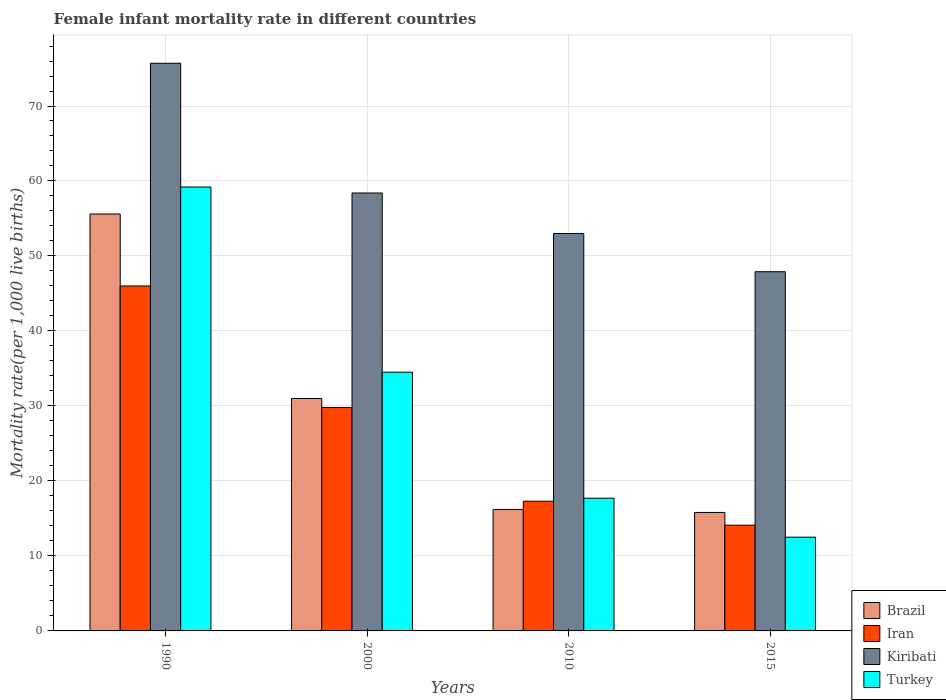How many groups of bars are there?
Offer a very short reply. 4. What is the label of the 4th group of bars from the left?
Provide a succinct answer. 2015. In which year was the female infant mortality rate in Turkey maximum?
Ensure brevity in your answer.  1990. In which year was the female infant mortality rate in Brazil minimum?
Make the answer very short. 2015. What is the total female infant mortality rate in Kiribati in the graph?
Your answer should be very brief. 235. What is the difference between the female infant mortality rate in Brazil in 1990 and that in 2015?
Offer a very short reply. 39.8. What is the difference between the female infant mortality rate in Kiribati in 2015 and the female infant mortality rate in Turkey in 1990?
Your response must be concise. -11.3. What is the average female infant mortality rate in Turkey per year?
Your answer should be compact. 30.98. In the year 2015, what is the difference between the female infant mortality rate in Turkey and female infant mortality rate in Iran?
Provide a succinct answer. -1.6. In how many years, is the female infant mortality rate in Kiribati greater than 2?
Your response must be concise. 4. What is the ratio of the female infant mortality rate in Iran in 1990 to that in 2000?
Offer a terse response. 1.54. What is the difference between the highest and the second highest female infant mortality rate in Iran?
Give a very brief answer. 16.2. What is the difference between the highest and the lowest female infant mortality rate in Iran?
Give a very brief answer. 31.9. Is the sum of the female infant mortality rate in Kiribati in 1990 and 2015 greater than the maximum female infant mortality rate in Turkey across all years?
Make the answer very short. Yes. Is it the case that in every year, the sum of the female infant mortality rate in Iran and female infant mortality rate in Brazil is greater than the sum of female infant mortality rate in Kiribati and female infant mortality rate in Turkey?
Keep it short and to the point. No. What does the 3rd bar from the right in 2015 represents?
Offer a terse response. Iran. How many bars are there?
Offer a very short reply. 16. How many years are there in the graph?
Make the answer very short. 4. Are the values on the major ticks of Y-axis written in scientific E-notation?
Keep it short and to the point. No. Does the graph contain any zero values?
Ensure brevity in your answer.  No. Where does the legend appear in the graph?
Offer a terse response. Bottom right. What is the title of the graph?
Keep it short and to the point. Female infant mortality rate in different countries. What is the label or title of the X-axis?
Keep it short and to the point. Years. What is the label or title of the Y-axis?
Ensure brevity in your answer.  Mortality rate(per 1,0 live births). What is the Mortality rate(per 1,000 live births) in Brazil in 1990?
Provide a short and direct response. 55.6. What is the Mortality rate(per 1,000 live births) in Kiribati in 1990?
Make the answer very short. 75.7. What is the Mortality rate(per 1,000 live births) of Turkey in 1990?
Offer a very short reply. 59.2. What is the Mortality rate(per 1,000 live births) of Iran in 2000?
Give a very brief answer. 29.8. What is the Mortality rate(per 1,000 live births) of Kiribati in 2000?
Give a very brief answer. 58.4. What is the Mortality rate(per 1,000 live births) in Turkey in 2000?
Offer a terse response. 34.5. What is the Mortality rate(per 1,000 live births) of Kiribati in 2010?
Your answer should be compact. 53. What is the Mortality rate(per 1,000 live births) of Turkey in 2010?
Make the answer very short. 17.7. What is the Mortality rate(per 1,000 live births) in Brazil in 2015?
Ensure brevity in your answer.  15.8. What is the Mortality rate(per 1,000 live births) of Iran in 2015?
Your response must be concise. 14.1. What is the Mortality rate(per 1,000 live births) in Kiribati in 2015?
Offer a very short reply. 47.9. Across all years, what is the maximum Mortality rate(per 1,000 live births) of Brazil?
Your answer should be compact. 55.6. Across all years, what is the maximum Mortality rate(per 1,000 live births) in Kiribati?
Your response must be concise. 75.7. Across all years, what is the maximum Mortality rate(per 1,000 live births) in Turkey?
Keep it short and to the point. 59.2. Across all years, what is the minimum Mortality rate(per 1,000 live births) of Brazil?
Your answer should be compact. 15.8. Across all years, what is the minimum Mortality rate(per 1,000 live births) in Iran?
Your answer should be compact. 14.1. Across all years, what is the minimum Mortality rate(per 1,000 live births) of Kiribati?
Your response must be concise. 47.9. Across all years, what is the minimum Mortality rate(per 1,000 live births) of Turkey?
Ensure brevity in your answer.  12.5. What is the total Mortality rate(per 1,000 live births) in Brazil in the graph?
Your answer should be compact. 118.6. What is the total Mortality rate(per 1,000 live births) in Iran in the graph?
Offer a terse response. 107.2. What is the total Mortality rate(per 1,000 live births) in Kiribati in the graph?
Your answer should be compact. 235. What is the total Mortality rate(per 1,000 live births) of Turkey in the graph?
Your answer should be very brief. 123.9. What is the difference between the Mortality rate(per 1,000 live births) of Brazil in 1990 and that in 2000?
Ensure brevity in your answer.  24.6. What is the difference between the Mortality rate(per 1,000 live births) in Iran in 1990 and that in 2000?
Your answer should be compact. 16.2. What is the difference between the Mortality rate(per 1,000 live births) in Turkey in 1990 and that in 2000?
Offer a very short reply. 24.7. What is the difference between the Mortality rate(per 1,000 live births) in Brazil in 1990 and that in 2010?
Keep it short and to the point. 39.4. What is the difference between the Mortality rate(per 1,000 live births) in Iran in 1990 and that in 2010?
Your response must be concise. 28.7. What is the difference between the Mortality rate(per 1,000 live births) of Kiribati in 1990 and that in 2010?
Your response must be concise. 22.7. What is the difference between the Mortality rate(per 1,000 live births) of Turkey in 1990 and that in 2010?
Offer a very short reply. 41.5. What is the difference between the Mortality rate(per 1,000 live births) in Brazil in 1990 and that in 2015?
Your response must be concise. 39.8. What is the difference between the Mortality rate(per 1,000 live births) in Iran in 1990 and that in 2015?
Make the answer very short. 31.9. What is the difference between the Mortality rate(per 1,000 live births) of Kiribati in 1990 and that in 2015?
Offer a terse response. 27.8. What is the difference between the Mortality rate(per 1,000 live births) in Turkey in 1990 and that in 2015?
Keep it short and to the point. 46.7. What is the difference between the Mortality rate(per 1,000 live births) of Brazil in 2000 and that in 2015?
Your answer should be compact. 15.2. What is the difference between the Mortality rate(per 1,000 live births) of Kiribati in 2000 and that in 2015?
Your answer should be compact. 10.5. What is the difference between the Mortality rate(per 1,000 live births) of Kiribati in 2010 and that in 2015?
Provide a succinct answer. 5.1. What is the difference between the Mortality rate(per 1,000 live births) in Turkey in 2010 and that in 2015?
Offer a very short reply. 5.2. What is the difference between the Mortality rate(per 1,000 live births) in Brazil in 1990 and the Mortality rate(per 1,000 live births) in Iran in 2000?
Your answer should be very brief. 25.8. What is the difference between the Mortality rate(per 1,000 live births) of Brazil in 1990 and the Mortality rate(per 1,000 live births) of Kiribati in 2000?
Give a very brief answer. -2.8. What is the difference between the Mortality rate(per 1,000 live births) in Brazil in 1990 and the Mortality rate(per 1,000 live births) in Turkey in 2000?
Offer a terse response. 21.1. What is the difference between the Mortality rate(per 1,000 live births) in Kiribati in 1990 and the Mortality rate(per 1,000 live births) in Turkey in 2000?
Offer a very short reply. 41.2. What is the difference between the Mortality rate(per 1,000 live births) of Brazil in 1990 and the Mortality rate(per 1,000 live births) of Iran in 2010?
Your response must be concise. 38.3. What is the difference between the Mortality rate(per 1,000 live births) in Brazil in 1990 and the Mortality rate(per 1,000 live births) in Kiribati in 2010?
Your answer should be very brief. 2.6. What is the difference between the Mortality rate(per 1,000 live births) in Brazil in 1990 and the Mortality rate(per 1,000 live births) in Turkey in 2010?
Your answer should be compact. 37.9. What is the difference between the Mortality rate(per 1,000 live births) of Iran in 1990 and the Mortality rate(per 1,000 live births) of Kiribati in 2010?
Your answer should be compact. -7. What is the difference between the Mortality rate(per 1,000 live births) of Iran in 1990 and the Mortality rate(per 1,000 live births) of Turkey in 2010?
Your answer should be compact. 28.3. What is the difference between the Mortality rate(per 1,000 live births) in Brazil in 1990 and the Mortality rate(per 1,000 live births) in Iran in 2015?
Ensure brevity in your answer.  41.5. What is the difference between the Mortality rate(per 1,000 live births) of Brazil in 1990 and the Mortality rate(per 1,000 live births) of Kiribati in 2015?
Your answer should be very brief. 7.7. What is the difference between the Mortality rate(per 1,000 live births) in Brazil in 1990 and the Mortality rate(per 1,000 live births) in Turkey in 2015?
Offer a terse response. 43.1. What is the difference between the Mortality rate(per 1,000 live births) of Iran in 1990 and the Mortality rate(per 1,000 live births) of Kiribati in 2015?
Provide a succinct answer. -1.9. What is the difference between the Mortality rate(per 1,000 live births) in Iran in 1990 and the Mortality rate(per 1,000 live births) in Turkey in 2015?
Offer a terse response. 33.5. What is the difference between the Mortality rate(per 1,000 live births) in Kiribati in 1990 and the Mortality rate(per 1,000 live births) in Turkey in 2015?
Offer a terse response. 63.2. What is the difference between the Mortality rate(per 1,000 live births) of Brazil in 2000 and the Mortality rate(per 1,000 live births) of Iran in 2010?
Provide a short and direct response. 13.7. What is the difference between the Mortality rate(per 1,000 live births) in Brazil in 2000 and the Mortality rate(per 1,000 live births) in Turkey in 2010?
Your answer should be very brief. 13.3. What is the difference between the Mortality rate(per 1,000 live births) of Iran in 2000 and the Mortality rate(per 1,000 live births) of Kiribati in 2010?
Provide a succinct answer. -23.2. What is the difference between the Mortality rate(per 1,000 live births) of Iran in 2000 and the Mortality rate(per 1,000 live births) of Turkey in 2010?
Offer a very short reply. 12.1. What is the difference between the Mortality rate(per 1,000 live births) in Kiribati in 2000 and the Mortality rate(per 1,000 live births) in Turkey in 2010?
Your response must be concise. 40.7. What is the difference between the Mortality rate(per 1,000 live births) in Brazil in 2000 and the Mortality rate(per 1,000 live births) in Kiribati in 2015?
Offer a very short reply. -16.9. What is the difference between the Mortality rate(per 1,000 live births) of Iran in 2000 and the Mortality rate(per 1,000 live births) of Kiribati in 2015?
Provide a succinct answer. -18.1. What is the difference between the Mortality rate(per 1,000 live births) in Iran in 2000 and the Mortality rate(per 1,000 live births) in Turkey in 2015?
Give a very brief answer. 17.3. What is the difference between the Mortality rate(per 1,000 live births) of Kiribati in 2000 and the Mortality rate(per 1,000 live births) of Turkey in 2015?
Provide a short and direct response. 45.9. What is the difference between the Mortality rate(per 1,000 live births) of Brazil in 2010 and the Mortality rate(per 1,000 live births) of Kiribati in 2015?
Give a very brief answer. -31.7. What is the difference between the Mortality rate(per 1,000 live births) in Iran in 2010 and the Mortality rate(per 1,000 live births) in Kiribati in 2015?
Make the answer very short. -30.6. What is the difference between the Mortality rate(per 1,000 live births) of Kiribati in 2010 and the Mortality rate(per 1,000 live births) of Turkey in 2015?
Provide a short and direct response. 40.5. What is the average Mortality rate(per 1,000 live births) of Brazil per year?
Your response must be concise. 29.65. What is the average Mortality rate(per 1,000 live births) of Iran per year?
Your answer should be compact. 26.8. What is the average Mortality rate(per 1,000 live births) in Kiribati per year?
Provide a short and direct response. 58.75. What is the average Mortality rate(per 1,000 live births) of Turkey per year?
Your response must be concise. 30.98. In the year 1990, what is the difference between the Mortality rate(per 1,000 live births) in Brazil and Mortality rate(per 1,000 live births) in Iran?
Your answer should be compact. 9.6. In the year 1990, what is the difference between the Mortality rate(per 1,000 live births) of Brazil and Mortality rate(per 1,000 live births) of Kiribati?
Your answer should be very brief. -20.1. In the year 1990, what is the difference between the Mortality rate(per 1,000 live births) of Brazil and Mortality rate(per 1,000 live births) of Turkey?
Provide a short and direct response. -3.6. In the year 1990, what is the difference between the Mortality rate(per 1,000 live births) of Iran and Mortality rate(per 1,000 live births) of Kiribati?
Offer a terse response. -29.7. In the year 1990, what is the difference between the Mortality rate(per 1,000 live births) of Iran and Mortality rate(per 1,000 live births) of Turkey?
Give a very brief answer. -13.2. In the year 2000, what is the difference between the Mortality rate(per 1,000 live births) of Brazil and Mortality rate(per 1,000 live births) of Iran?
Your response must be concise. 1.2. In the year 2000, what is the difference between the Mortality rate(per 1,000 live births) in Brazil and Mortality rate(per 1,000 live births) in Kiribati?
Your response must be concise. -27.4. In the year 2000, what is the difference between the Mortality rate(per 1,000 live births) in Iran and Mortality rate(per 1,000 live births) in Kiribati?
Keep it short and to the point. -28.6. In the year 2000, what is the difference between the Mortality rate(per 1,000 live births) in Iran and Mortality rate(per 1,000 live births) in Turkey?
Provide a short and direct response. -4.7. In the year 2000, what is the difference between the Mortality rate(per 1,000 live births) in Kiribati and Mortality rate(per 1,000 live births) in Turkey?
Offer a terse response. 23.9. In the year 2010, what is the difference between the Mortality rate(per 1,000 live births) in Brazil and Mortality rate(per 1,000 live births) in Iran?
Provide a short and direct response. -1.1. In the year 2010, what is the difference between the Mortality rate(per 1,000 live births) in Brazil and Mortality rate(per 1,000 live births) in Kiribati?
Keep it short and to the point. -36.8. In the year 2010, what is the difference between the Mortality rate(per 1,000 live births) in Brazil and Mortality rate(per 1,000 live births) in Turkey?
Provide a short and direct response. -1.5. In the year 2010, what is the difference between the Mortality rate(per 1,000 live births) in Iran and Mortality rate(per 1,000 live births) in Kiribati?
Offer a terse response. -35.7. In the year 2010, what is the difference between the Mortality rate(per 1,000 live births) of Kiribati and Mortality rate(per 1,000 live births) of Turkey?
Your answer should be compact. 35.3. In the year 2015, what is the difference between the Mortality rate(per 1,000 live births) of Brazil and Mortality rate(per 1,000 live births) of Iran?
Your answer should be very brief. 1.7. In the year 2015, what is the difference between the Mortality rate(per 1,000 live births) of Brazil and Mortality rate(per 1,000 live births) of Kiribati?
Keep it short and to the point. -32.1. In the year 2015, what is the difference between the Mortality rate(per 1,000 live births) in Brazil and Mortality rate(per 1,000 live births) in Turkey?
Provide a short and direct response. 3.3. In the year 2015, what is the difference between the Mortality rate(per 1,000 live births) of Iran and Mortality rate(per 1,000 live births) of Kiribati?
Keep it short and to the point. -33.8. In the year 2015, what is the difference between the Mortality rate(per 1,000 live births) of Kiribati and Mortality rate(per 1,000 live births) of Turkey?
Ensure brevity in your answer.  35.4. What is the ratio of the Mortality rate(per 1,000 live births) of Brazil in 1990 to that in 2000?
Your answer should be very brief. 1.79. What is the ratio of the Mortality rate(per 1,000 live births) in Iran in 1990 to that in 2000?
Offer a very short reply. 1.54. What is the ratio of the Mortality rate(per 1,000 live births) of Kiribati in 1990 to that in 2000?
Provide a succinct answer. 1.3. What is the ratio of the Mortality rate(per 1,000 live births) of Turkey in 1990 to that in 2000?
Your response must be concise. 1.72. What is the ratio of the Mortality rate(per 1,000 live births) of Brazil in 1990 to that in 2010?
Make the answer very short. 3.43. What is the ratio of the Mortality rate(per 1,000 live births) of Iran in 1990 to that in 2010?
Your answer should be very brief. 2.66. What is the ratio of the Mortality rate(per 1,000 live births) of Kiribati in 1990 to that in 2010?
Your response must be concise. 1.43. What is the ratio of the Mortality rate(per 1,000 live births) in Turkey in 1990 to that in 2010?
Provide a succinct answer. 3.34. What is the ratio of the Mortality rate(per 1,000 live births) in Brazil in 1990 to that in 2015?
Ensure brevity in your answer.  3.52. What is the ratio of the Mortality rate(per 1,000 live births) of Iran in 1990 to that in 2015?
Ensure brevity in your answer.  3.26. What is the ratio of the Mortality rate(per 1,000 live births) in Kiribati in 1990 to that in 2015?
Your answer should be compact. 1.58. What is the ratio of the Mortality rate(per 1,000 live births) in Turkey in 1990 to that in 2015?
Provide a short and direct response. 4.74. What is the ratio of the Mortality rate(per 1,000 live births) of Brazil in 2000 to that in 2010?
Make the answer very short. 1.91. What is the ratio of the Mortality rate(per 1,000 live births) of Iran in 2000 to that in 2010?
Make the answer very short. 1.72. What is the ratio of the Mortality rate(per 1,000 live births) in Kiribati in 2000 to that in 2010?
Your response must be concise. 1.1. What is the ratio of the Mortality rate(per 1,000 live births) in Turkey in 2000 to that in 2010?
Your answer should be very brief. 1.95. What is the ratio of the Mortality rate(per 1,000 live births) of Brazil in 2000 to that in 2015?
Offer a very short reply. 1.96. What is the ratio of the Mortality rate(per 1,000 live births) of Iran in 2000 to that in 2015?
Offer a very short reply. 2.11. What is the ratio of the Mortality rate(per 1,000 live births) of Kiribati in 2000 to that in 2015?
Provide a succinct answer. 1.22. What is the ratio of the Mortality rate(per 1,000 live births) in Turkey in 2000 to that in 2015?
Ensure brevity in your answer.  2.76. What is the ratio of the Mortality rate(per 1,000 live births) in Brazil in 2010 to that in 2015?
Provide a short and direct response. 1.03. What is the ratio of the Mortality rate(per 1,000 live births) of Iran in 2010 to that in 2015?
Make the answer very short. 1.23. What is the ratio of the Mortality rate(per 1,000 live births) of Kiribati in 2010 to that in 2015?
Keep it short and to the point. 1.11. What is the ratio of the Mortality rate(per 1,000 live births) of Turkey in 2010 to that in 2015?
Your answer should be very brief. 1.42. What is the difference between the highest and the second highest Mortality rate(per 1,000 live births) in Brazil?
Your answer should be very brief. 24.6. What is the difference between the highest and the second highest Mortality rate(per 1,000 live births) in Iran?
Your answer should be compact. 16.2. What is the difference between the highest and the second highest Mortality rate(per 1,000 live births) in Kiribati?
Your answer should be compact. 17.3. What is the difference between the highest and the second highest Mortality rate(per 1,000 live births) in Turkey?
Offer a terse response. 24.7. What is the difference between the highest and the lowest Mortality rate(per 1,000 live births) in Brazil?
Your answer should be compact. 39.8. What is the difference between the highest and the lowest Mortality rate(per 1,000 live births) of Iran?
Provide a succinct answer. 31.9. What is the difference between the highest and the lowest Mortality rate(per 1,000 live births) in Kiribati?
Your answer should be very brief. 27.8. What is the difference between the highest and the lowest Mortality rate(per 1,000 live births) of Turkey?
Provide a succinct answer. 46.7. 